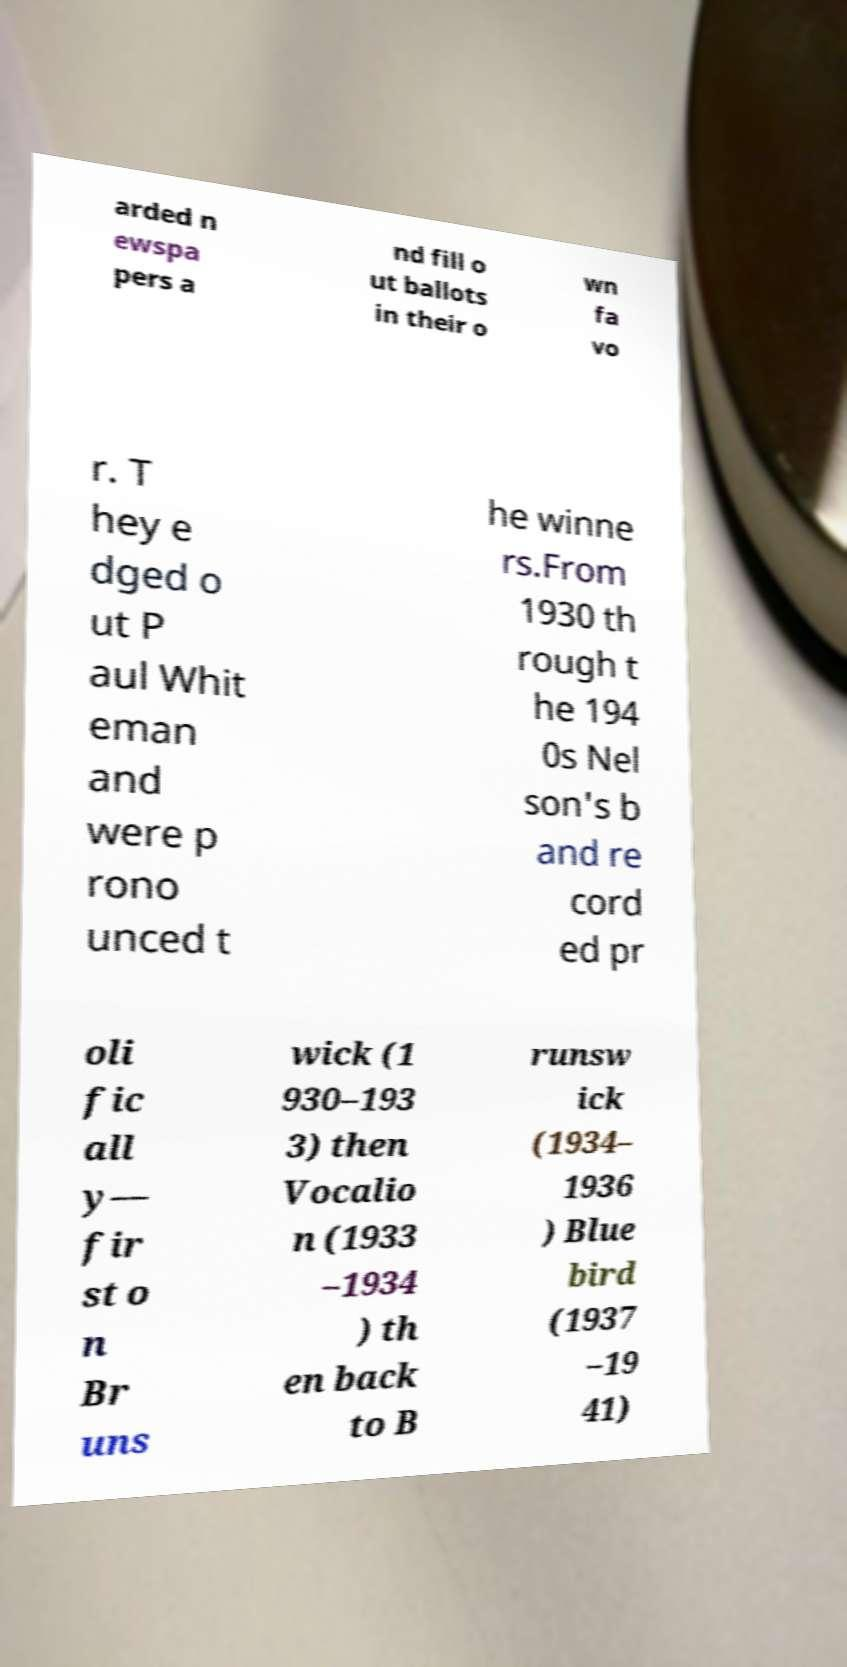For documentation purposes, I need the text within this image transcribed. Could you provide that? arded n ewspa pers a nd fill o ut ballots in their o wn fa vo r. T hey e dged o ut P aul Whit eman and were p rono unced t he winne rs.From 1930 th rough t he 194 0s Nel son's b and re cord ed pr oli fic all y— fir st o n Br uns wick (1 930–193 3) then Vocalio n (1933 –1934 ) th en back to B runsw ick (1934– 1936 ) Blue bird (1937 –19 41) 